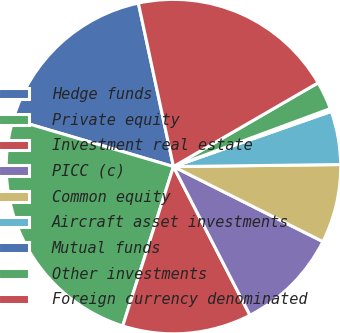<chart> <loc_0><loc_0><loc_500><loc_500><pie_chart><fcel>Hedge funds<fcel>Private equity<fcel>Investment real estate<fcel>PICC (c)<fcel>Common equity<fcel>Aircraft asset investments<fcel>Mutual funds<fcel>Other investments<fcel>Foreign currency denominated<nl><fcel>17.07%<fcel>24.66%<fcel>12.47%<fcel>10.03%<fcel>7.6%<fcel>5.16%<fcel>0.28%<fcel>2.72%<fcel>20.01%<nl></chart> 